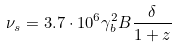Convert formula to latex. <formula><loc_0><loc_0><loc_500><loc_500>\nu _ { s } = 3 . 7 \cdot 1 0 ^ { 6 } \gamma _ { b } ^ { 2 } B \frac { \delta } { 1 + z }</formula> 